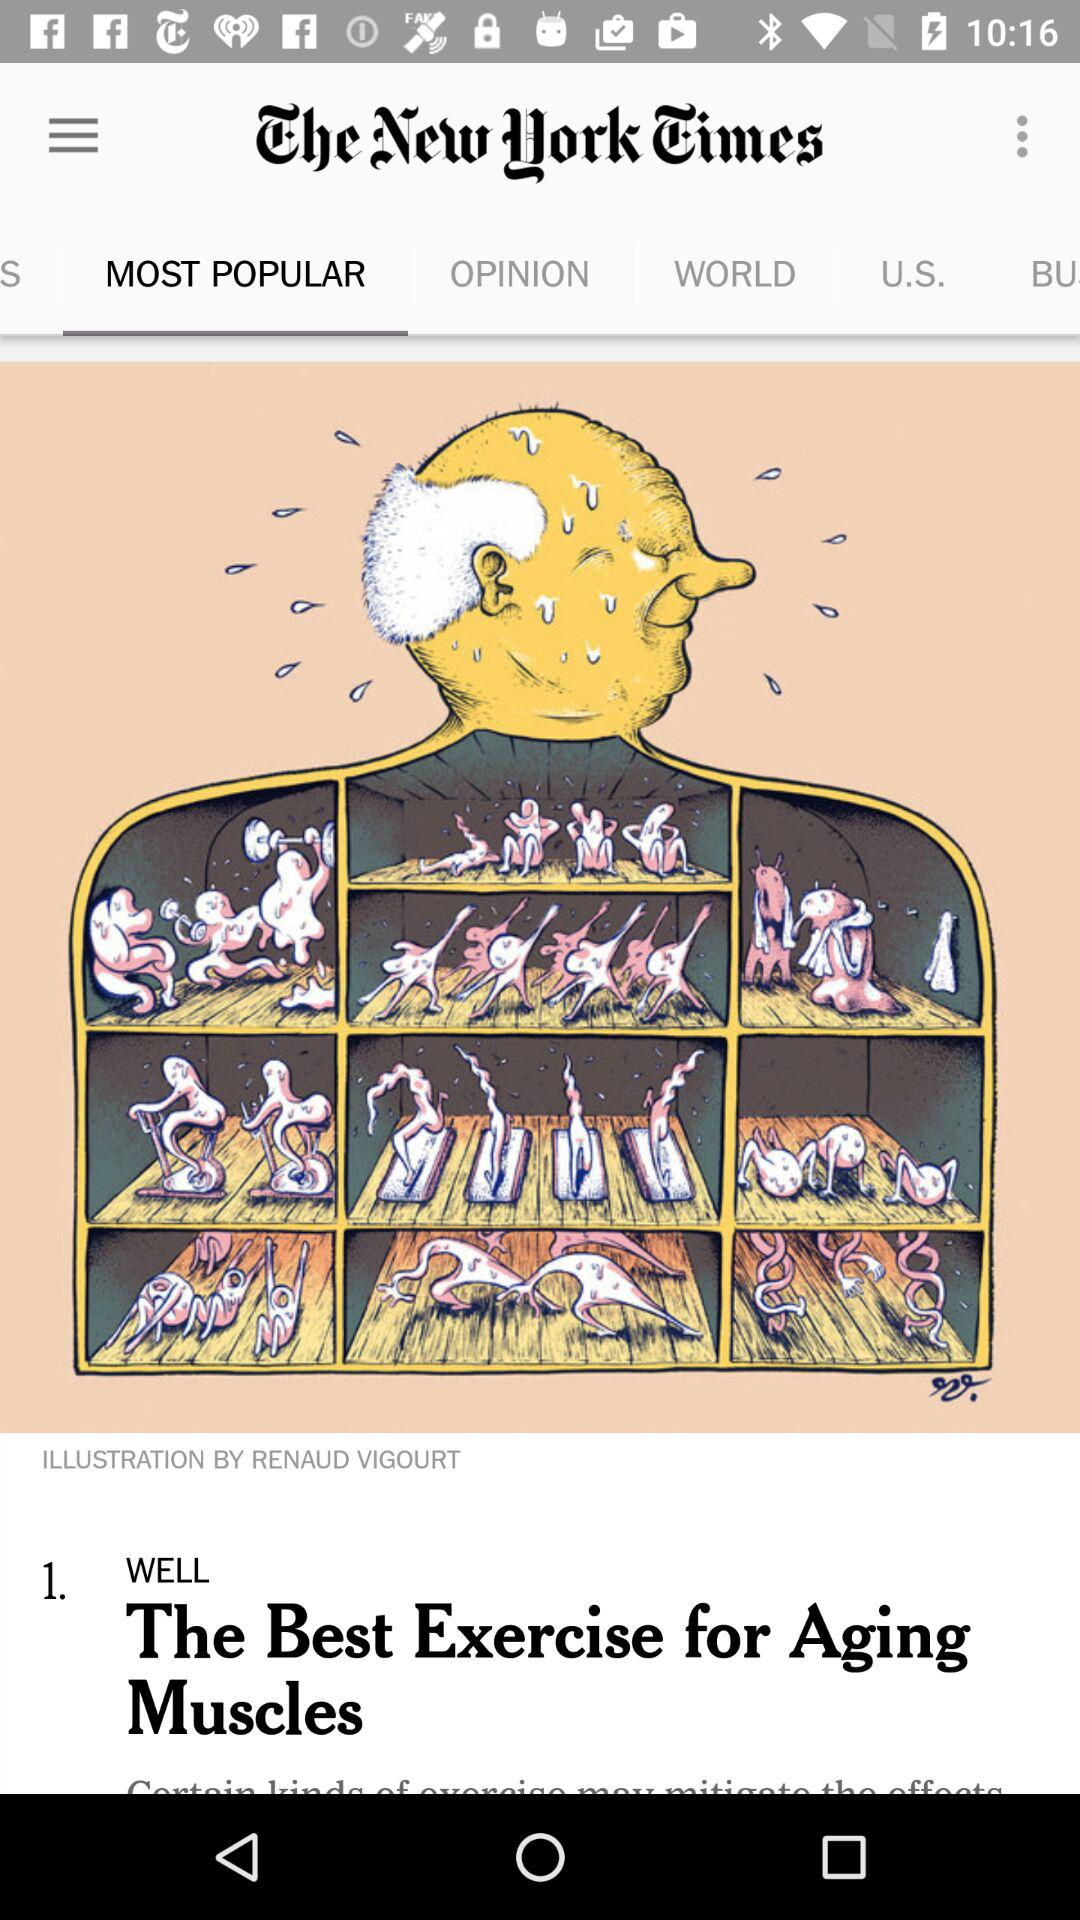Which tab is selected? The selected tab is "MOST POPULAR". 